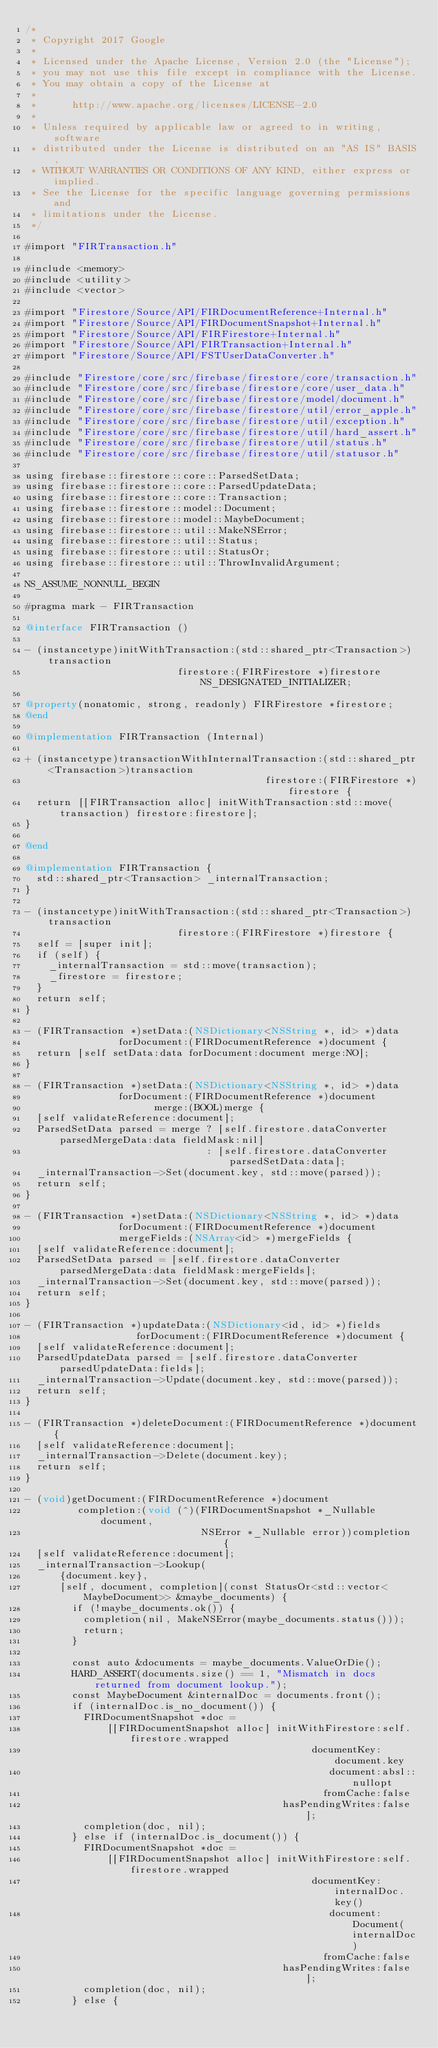<code> <loc_0><loc_0><loc_500><loc_500><_ObjectiveC_>/*
 * Copyright 2017 Google
 *
 * Licensed under the Apache License, Version 2.0 (the "License");
 * you may not use this file except in compliance with the License.
 * You may obtain a copy of the License at
 *
 *      http://www.apache.org/licenses/LICENSE-2.0
 *
 * Unless required by applicable law or agreed to in writing, software
 * distributed under the License is distributed on an "AS IS" BASIS,
 * WITHOUT WARRANTIES OR CONDITIONS OF ANY KIND, either express or implied.
 * See the License for the specific language governing permissions and
 * limitations under the License.
 */

#import "FIRTransaction.h"

#include <memory>
#include <utility>
#include <vector>

#import "Firestore/Source/API/FIRDocumentReference+Internal.h"
#import "Firestore/Source/API/FIRDocumentSnapshot+Internal.h"
#import "Firestore/Source/API/FIRFirestore+Internal.h"
#import "Firestore/Source/API/FIRTransaction+Internal.h"
#import "Firestore/Source/API/FSTUserDataConverter.h"

#include "Firestore/core/src/firebase/firestore/core/transaction.h"
#include "Firestore/core/src/firebase/firestore/core/user_data.h"
#include "Firestore/core/src/firebase/firestore/model/document.h"
#include "Firestore/core/src/firebase/firestore/util/error_apple.h"
#include "Firestore/core/src/firebase/firestore/util/exception.h"
#include "Firestore/core/src/firebase/firestore/util/hard_assert.h"
#include "Firestore/core/src/firebase/firestore/util/status.h"
#include "Firestore/core/src/firebase/firestore/util/statusor.h"

using firebase::firestore::core::ParsedSetData;
using firebase::firestore::core::ParsedUpdateData;
using firebase::firestore::core::Transaction;
using firebase::firestore::model::Document;
using firebase::firestore::model::MaybeDocument;
using firebase::firestore::util::MakeNSError;
using firebase::firestore::util::Status;
using firebase::firestore::util::StatusOr;
using firebase::firestore::util::ThrowInvalidArgument;

NS_ASSUME_NONNULL_BEGIN

#pragma mark - FIRTransaction

@interface FIRTransaction ()

- (instancetype)initWithTransaction:(std::shared_ptr<Transaction>)transaction
                          firestore:(FIRFirestore *)firestore NS_DESIGNATED_INITIALIZER;

@property(nonatomic, strong, readonly) FIRFirestore *firestore;
@end

@implementation FIRTransaction (Internal)

+ (instancetype)transactionWithInternalTransaction:(std::shared_ptr<Transaction>)transaction
                                         firestore:(FIRFirestore *)firestore {
  return [[FIRTransaction alloc] initWithTransaction:std::move(transaction) firestore:firestore];
}

@end

@implementation FIRTransaction {
  std::shared_ptr<Transaction> _internalTransaction;
}

- (instancetype)initWithTransaction:(std::shared_ptr<Transaction>)transaction
                          firestore:(FIRFirestore *)firestore {
  self = [super init];
  if (self) {
    _internalTransaction = std::move(transaction);
    _firestore = firestore;
  }
  return self;
}

- (FIRTransaction *)setData:(NSDictionary<NSString *, id> *)data
                forDocument:(FIRDocumentReference *)document {
  return [self setData:data forDocument:document merge:NO];
}

- (FIRTransaction *)setData:(NSDictionary<NSString *, id> *)data
                forDocument:(FIRDocumentReference *)document
                      merge:(BOOL)merge {
  [self validateReference:document];
  ParsedSetData parsed = merge ? [self.firestore.dataConverter parsedMergeData:data fieldMask:nil]
                               : [self.firestore.dataConverter parsedSetData:data];
  _internalTransaction->Set(document.key, std::move(parsed));
  return self;
}

- (FIRTransaction *)setData:(NSDictionary<NSString *, id> *)data
                forDocument:(FIRDocumentReference *)document
                mergeFields:(NSArray<id> *)mergeFields {
  [self validateReference:document];
  ParsedSetData parsed = [self.firestore.dataConverter parsedMergeData:data fieldMask:mergeFields];
  _internalTransaction->Set(document.key, std::move(parsed));
  return self;
}

- (FIRTransaction *)updateData:(NSDictionary<id, id> *)fields
                   forDocument:(FIRDocumentReference *)document {
  [self validateReference:document];
  ParsedUpdateData parsed = [self.firestore.dataConverter parsedUpdateData:fields];
  _internalTransaction->Update(document.key, std::move(parsed));
  return self;
}

- (FIRTransaction *)deleteDocument:(FIRDocumentReference *)document {
  [self validateReference:document];
  _internalTransaction->Delete(document.key);
  return self;
}

- (void)getDocument:(FIRDocumentReference *)document
         completion:(void (^)(FIRDocumentSnapshot *_Nullable document,
                              NSError *_Nullable error))completion {
  [self validateReference:document];
  _internalTransaction->Lookup(
      {document.key},
      [self, document, completion](const StatusOr<std::vector<MaybeDocument>> &maybe_documents) {
        if (!maybe_documents.ok()) {
          completion(nil, MakeNSError(maybe_documents.status()));
          return;
        }

        const auto &documents = maybe_documents.ValueOrDie();
        HARD_ASSERT(documents.size() == 1, "Mismatch in docs returned from document lookup.");
        const MaybeDocument &internalDoc = documents.front();
        if (internalDoc.is_no_document()) {
          FIRDocumentSnapshot *doc =
              [[FIRDocumentSnapshot alloc] initWithFirestore:self.firestore.wrapped
                                                 documentKey:document.key
                                                    document:absl::nullopt
                                                   fromCache:false
                                            hasPendingWrites:false];
          completion(doc, nil);
        } else if (internalDoc.is_document()) {
          FIRDocumentSnapshot *doc =
              [[FIRDocumentSnapshot alloc] initWithFirestore:self.firestore.wrapped
                                                 documentKey:internalDoc.key()
                                                    document:Document(internalDoc)
                                                   fromCache:false
                                            hasPendingWrites:false];
          completion(doc, nil);
        } else {</code> 